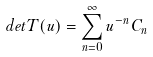Convert formula to latex. <formula><loc_0><loc_0><loc_500><loc_500>d e t T ( u ) = \sum ^ { \infty } _ { n = 0 } u ^ { - n } C _ { n }</formula> 